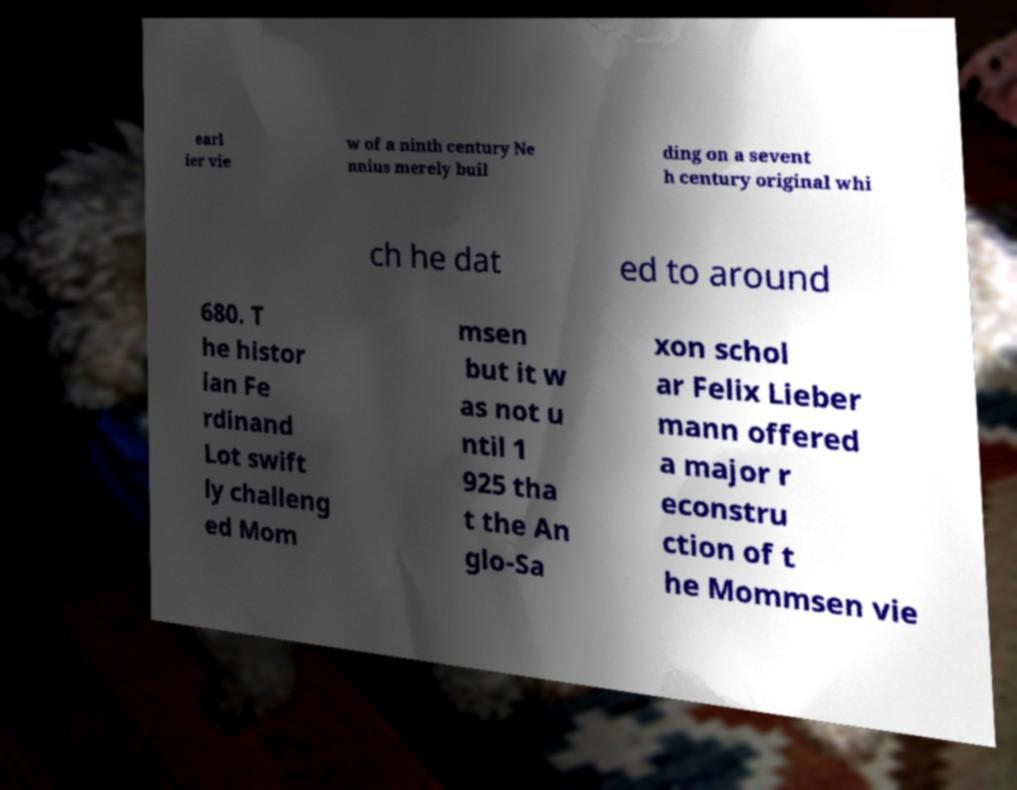Please identify and transcribe the text found in this image. earl ier vie w of a ninth century Ne nnius merely buil ding on a sevent h century original whi ch he dat ed to around 680. T he histor ian Fe rdinand Lot swift ly challeng ed Mom msen but it w as not u ntil 1 925 tha t the An glo-Sa xon schol ar Felix Lieber mann offered a major r econstru ction of t he Mommsen vie 